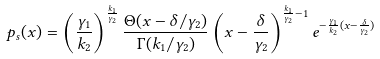Convert formula to latex. <formula><loc_0><loc_0><loc_500><loc_500>p _ { s } ( x ) = \left ( \frac { \gamma _ { 1 } } { k _ { 2 } } \right ) ^ { \frac { k _ { 1 } } { \gamma _ { 2 } } } \frac { \Theta ( x - \delta / \gamma _ { 2 } ) } { \Gamma ( k _ { 1 } / \gamma _ { 2 } ) } \left ( x - \frac { \delta } { \gamma _ { 2 } } \right ) ^ { \frac { k _ { 1 } } { \gamma _ { 2 } } - 1 } e ^ { - \frac { \gamma _ { 1 } } { k _ { 2 } } ( x - \frac { \delta } { \gamma _ { 2 } } ) }</formula> 